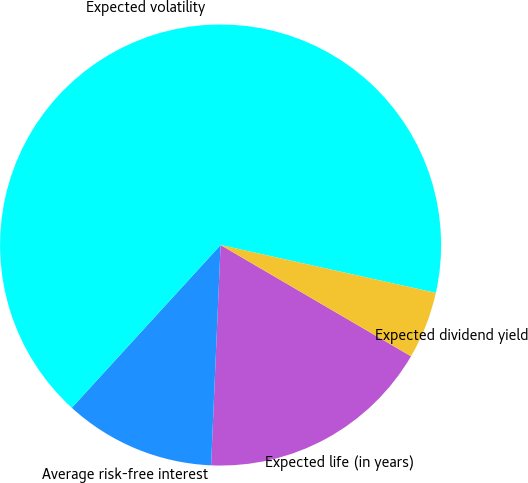Convert chart to OTSL. <chart><loc_0><loc_0><loc_500><loc_500><pie_chart><fcel>Expected life (in years)<fcel>Average risk-free interest<fcel>Expected volatility<fcel>Expected dividend yield<nl><fcel>17.27%<fcel>11.1%<fcel>66.69%<fcel>4.93%<nl></chart> 